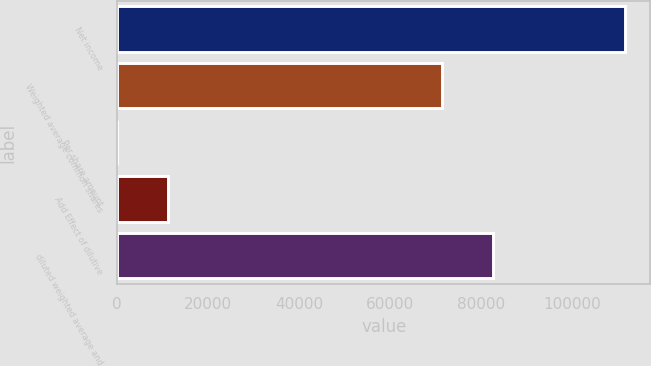<chart> <loc_0><loc_0><loc_500><loc_500><bar_chart><fcel>Net income<fcel>Weighted average common shares<fcel>Per share amount<fcel>Add Effect of dilutive<fcel>diluted weighted average and<nl><fcel>111603<fcel>71364<fcel>1.56<fcel>11161.7<fcel>82524.1<nl></chart> 